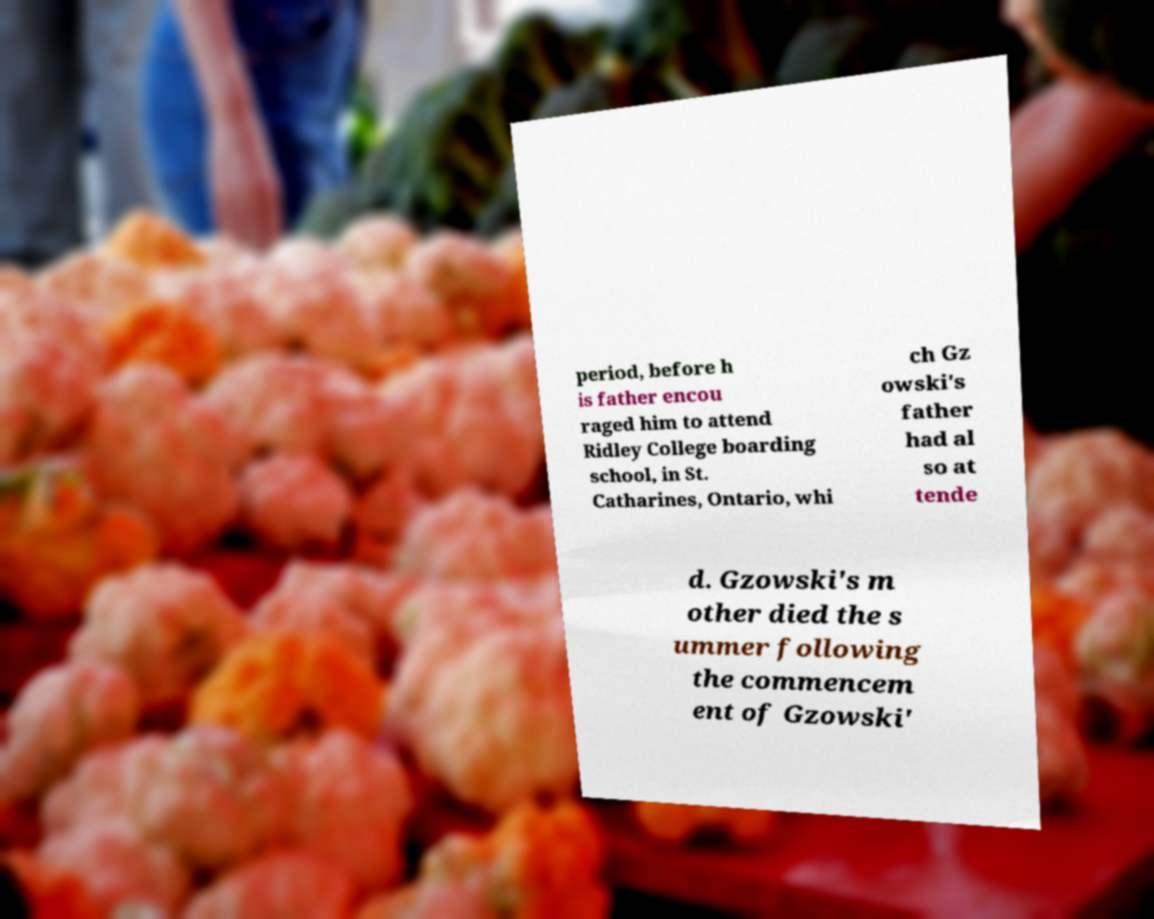Could you assist in decoding the text presented in this image and type it out clearly? period, before h is father encou raged him to attend Ridley College boarding school, in St. Catharines, Ontario, whi ch Gz owski's father had al so at tende d. Gzowski's m other died the s ummer following the commencem ent of Gzowski' 